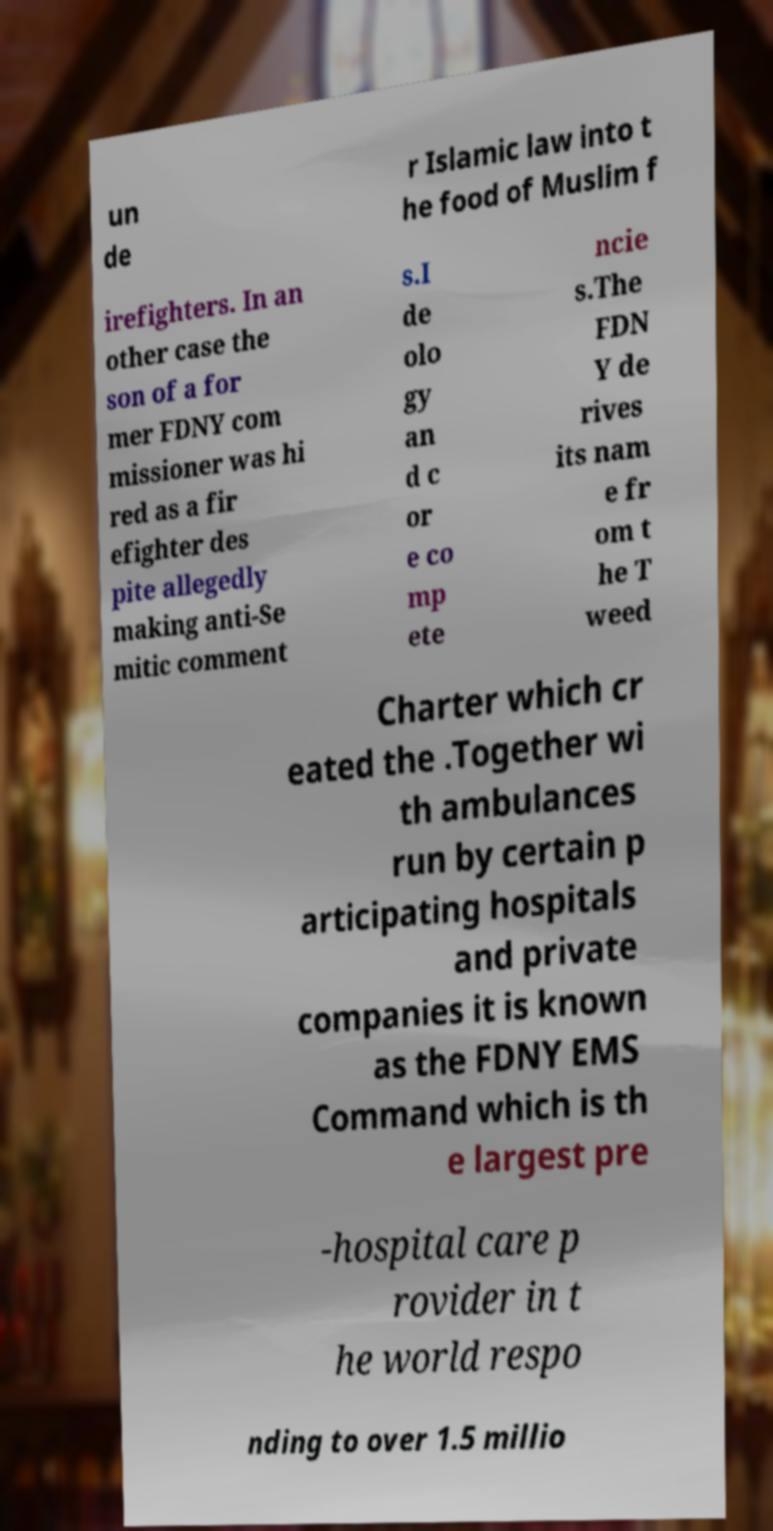Please read and relay the text visible in this image. What does it say? un de r Islamic law into t he food of Muslim f irefighters. In an other case the son of a for mer FDNY com missioner was hi red as a fir efighter des pite allegedly making anti-Se mitic comment s.I de olo gy an d c or e co mp ete ncie s.The FDN Y de rives its nam e fr om t he T weed Charter which cr eated the .Together wi th ambulances run by certain p articipating hospitals and private companies it is known as the FDNY EMS Command which is th e largest pre -hospital care p rovider in t he world respo nding to over 1.5 millio 